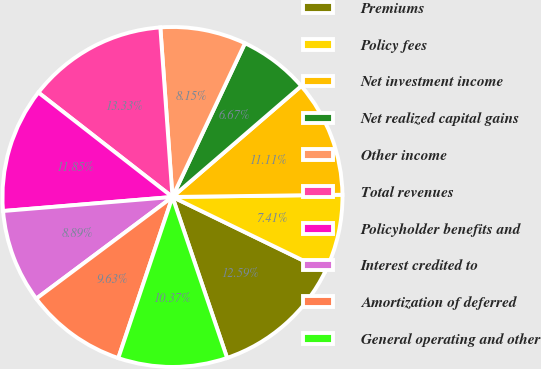Convert chart. <chart><loc_0><loc_0><loc_500><loc_500><pie_chart><fcel>Premiums<fcel>Policy fees<fcel>Net investment income<fcel>Net realized capital gains<fcel>Other income<fcel>Total revenues<fcel>Policyholder benefits and<fcel>Interest credited to<fcel>Amortization of deferred<fcel>General operating and other<nl><fcel>12.59%<fcel>7.41%<fcel>11.11%<fcel>6.67%<fcel>8.15%<fcel>13.33%<fcel>11.85%<fcel>8.89%<fcel>9.63%<fcel>10.37%<nl></chart> 